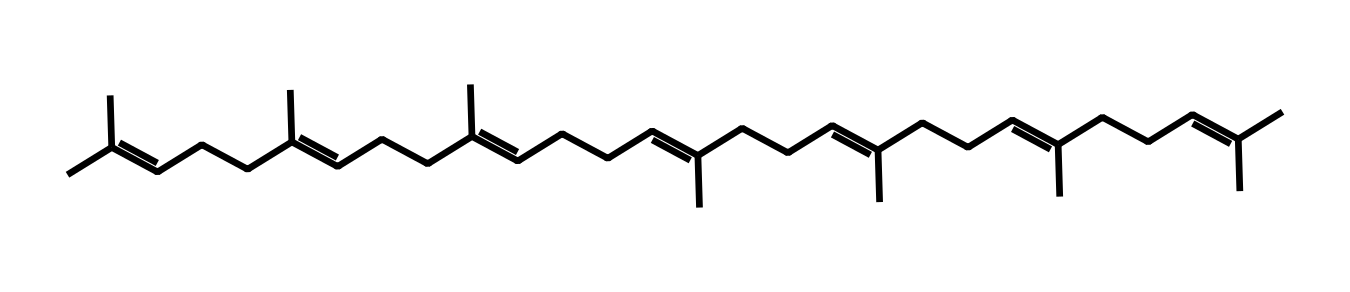What is the common name of this vitamin? The structure provided corresponds to Vitamin K2, specifically menaquinone, primarily known for its role in blood clotting and cardiovascular health.
Answer: Vitamin K2 How many double bonds are present in the chemical structure? By analyzing the SMILES representation, we count the '=' signs which indicate double bonds. There are 7 double bonds in this chemical structure.
Answer: 7 What is the main functional group characterizing Vitamin K2? The compound is characterized by a long hydrophobic tail with a series of conjugated double bonds typical of the vitamin's structure, specifically the presence of multiple alkenes and a prenyl side chain.
Answer: Alkene What is the significance of Vitamin K2 for men over 40 concerning cardiovascular health? Vitamin K2 plays a critical role in calcium metabolism, helping to prevent arterial calcification, which is particularly important for cardiovascular health in older men.
Answer: Calcium metabolism How does the structure of Vitamin K2 contribute to its fat-solubility? The long hydrophobic carbon chain in the structure allows it to dissolve in fats and oils, indicating its lipophilic nature, a property important for its absorption in the body.
Answer: Lipophilic Which molecular elements are predominantly found in Vitamin K2? The structure contains a large number of carbon (C) and hydrogen (H) atoms, with some presence of oxygen (O), indicating a typical organic compound structure.
Answer: Carbon and hydrogen What type of interactions would the double bonds in Vitamin K2 engage in? The double bonds make Vitamin K2 likely to engage in pi-bonding interactions, contributing to its biochemical activity and stability in membranes.
Answer: Pi-bonding interactions 